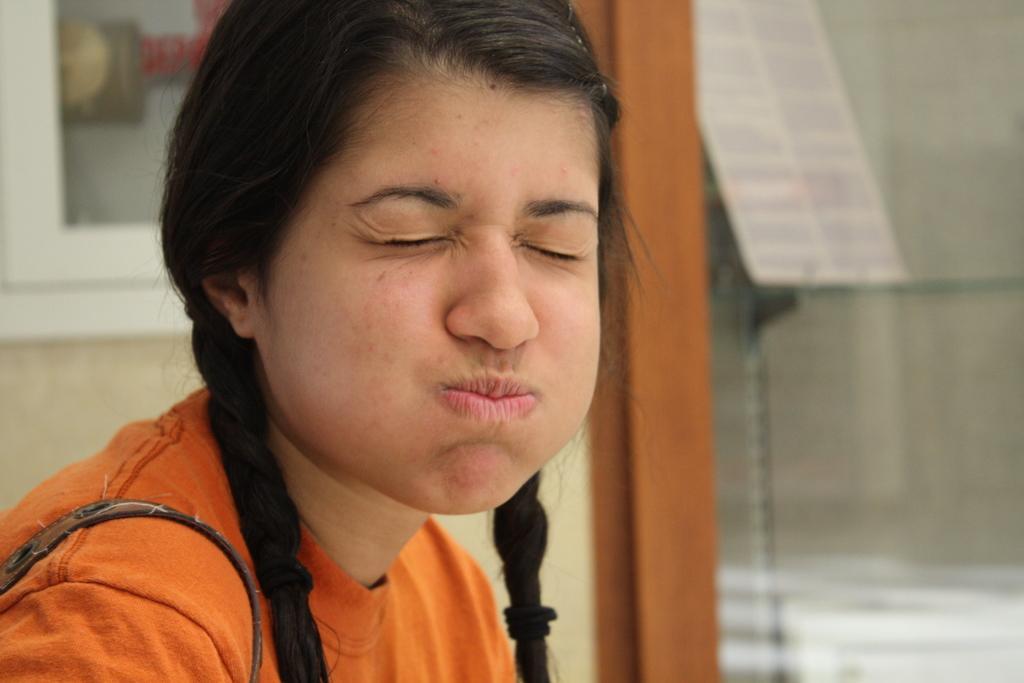Can you describe this image briefly? In this image there is a girl sitting, in the background it is blurred. 